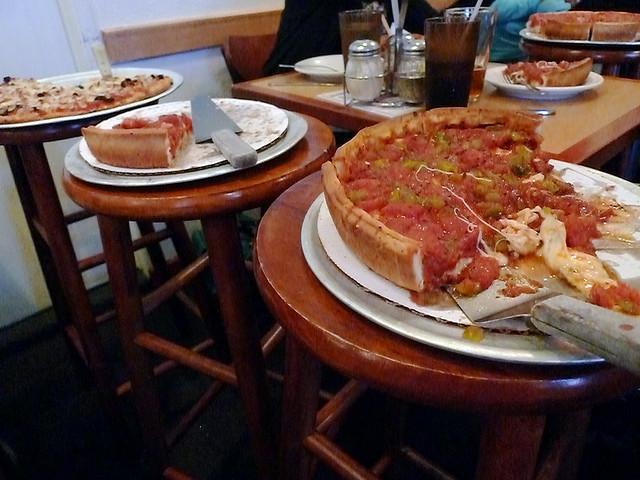How many dining tables are visible?
Give a very brief answer. 3. How many people are there?
Give a very brief answer. 2. How many knives can be seen?
Give a very brief answer. 2. How many pizzas are there?
Give a very brief answer. 4. How many clocks are on the wall?
Give a very brief answer. 0. 